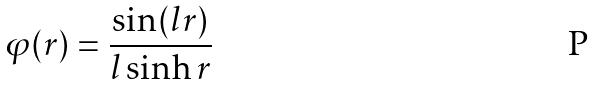<formula> <loc_0><loc_0><loc_500><loc_500>\varphi ( r ) = \frac { \sin ( l r ) } { l \sinh r }</formula> 